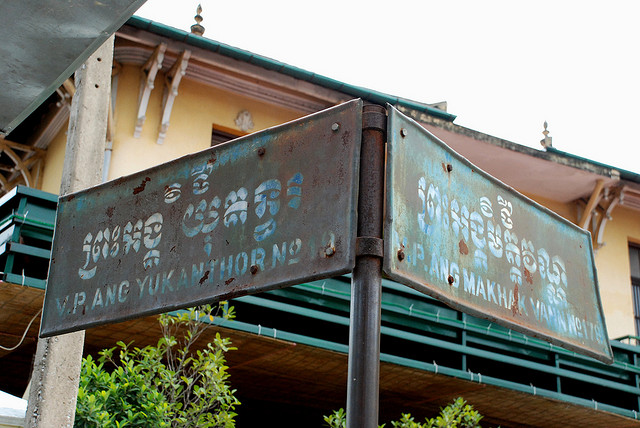Please transcribe the text in this image. V P ANG YUKANYHORN VANN NO 178 GMAKHAK ANG 